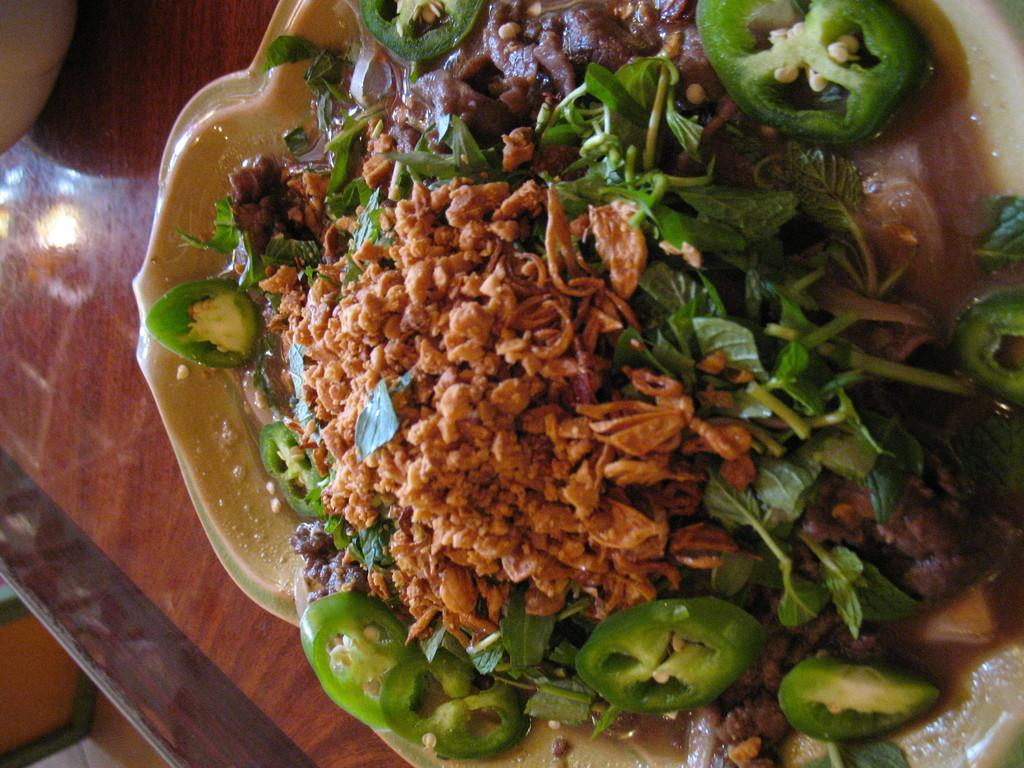What type of food can be seen in the image? The food in the image has brown and green colors. What is the color of the table on which the food is placed? The food is on a brown table. Where is the jar of bun placed in the image? There is no jar or bun present in the image. What type of scarf is draped over the food in the image? There is no scarf present in the image; the food is simply placed on the brown table. 